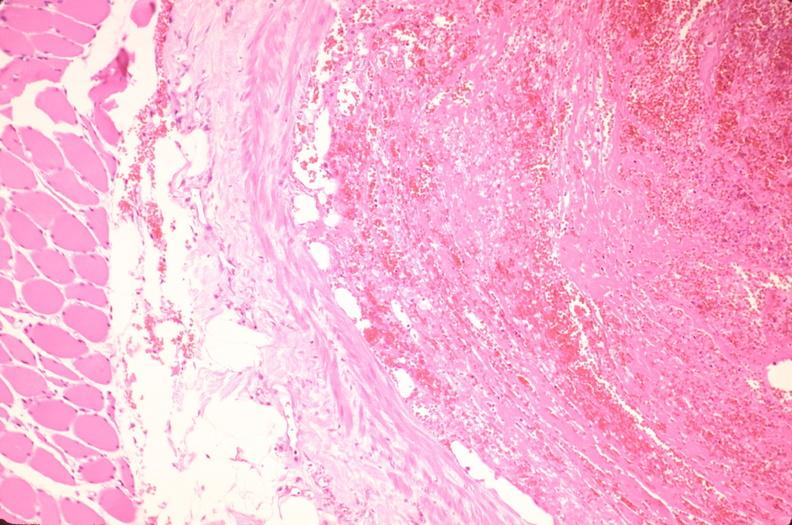how does this image show thrombus in leg vein?
Answer the question using a single word or phrase. With early organization 